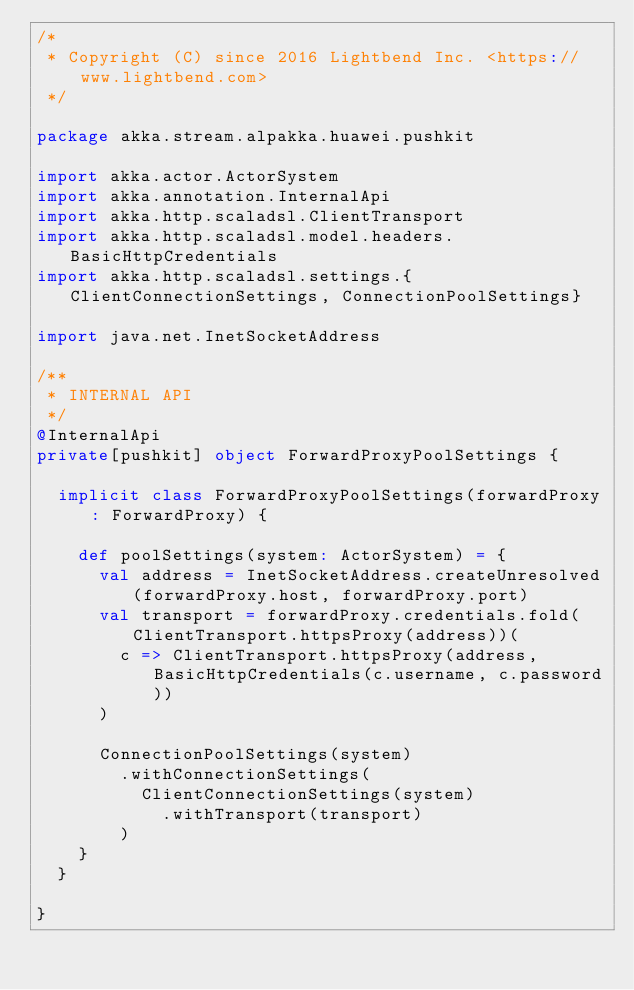Convert code to text. <code><loc_0><loc_0><loc_500><loc_500><_Scala_>/*
 * Copyright (C) since 2016 Lightbend Inc. <https://www.lightbend.com>
 */

package akka.stream.alpakka.huawei.pushkit

import akka.actor.ActorSystem
import akka.annotation.InternalApi
import akka.http.scaladsl.ClientTransport
import akka.http.scaladsl.model.headers.BasicHttpCredentials
import akka.http.scaladsl.settings.{ClientConnectionSettings, ConnectionPoolSettings}

import java.net.InetSocketAddress

/**
 * INTERNAL API
 */
@InternalApi
private[pushkit] object ForwardProxyPoolSettings {

  implicit class ForwardProxyPoolSettings(forwardProxy: ForwardProxy) {

    def poolSettings(system: ActorSystem) = {
      val address = InetSocketAddress.createUnresolved(forwardProxy.host, forwardProxy.port)
      val transport = forwardProxy.credentials.fold(ClientTransport.httpsProxy(address))(
        c => ClientTransport.httpsProxy(address, BasicHttpCredentials(c.username, c.password))
      )

      ConnectionPoolSettings(system)
        .withConnectionSettings(
          ClientConnectionSettings(system)
            .withTransport(transport)
        )
    }
  }

}
</code> 